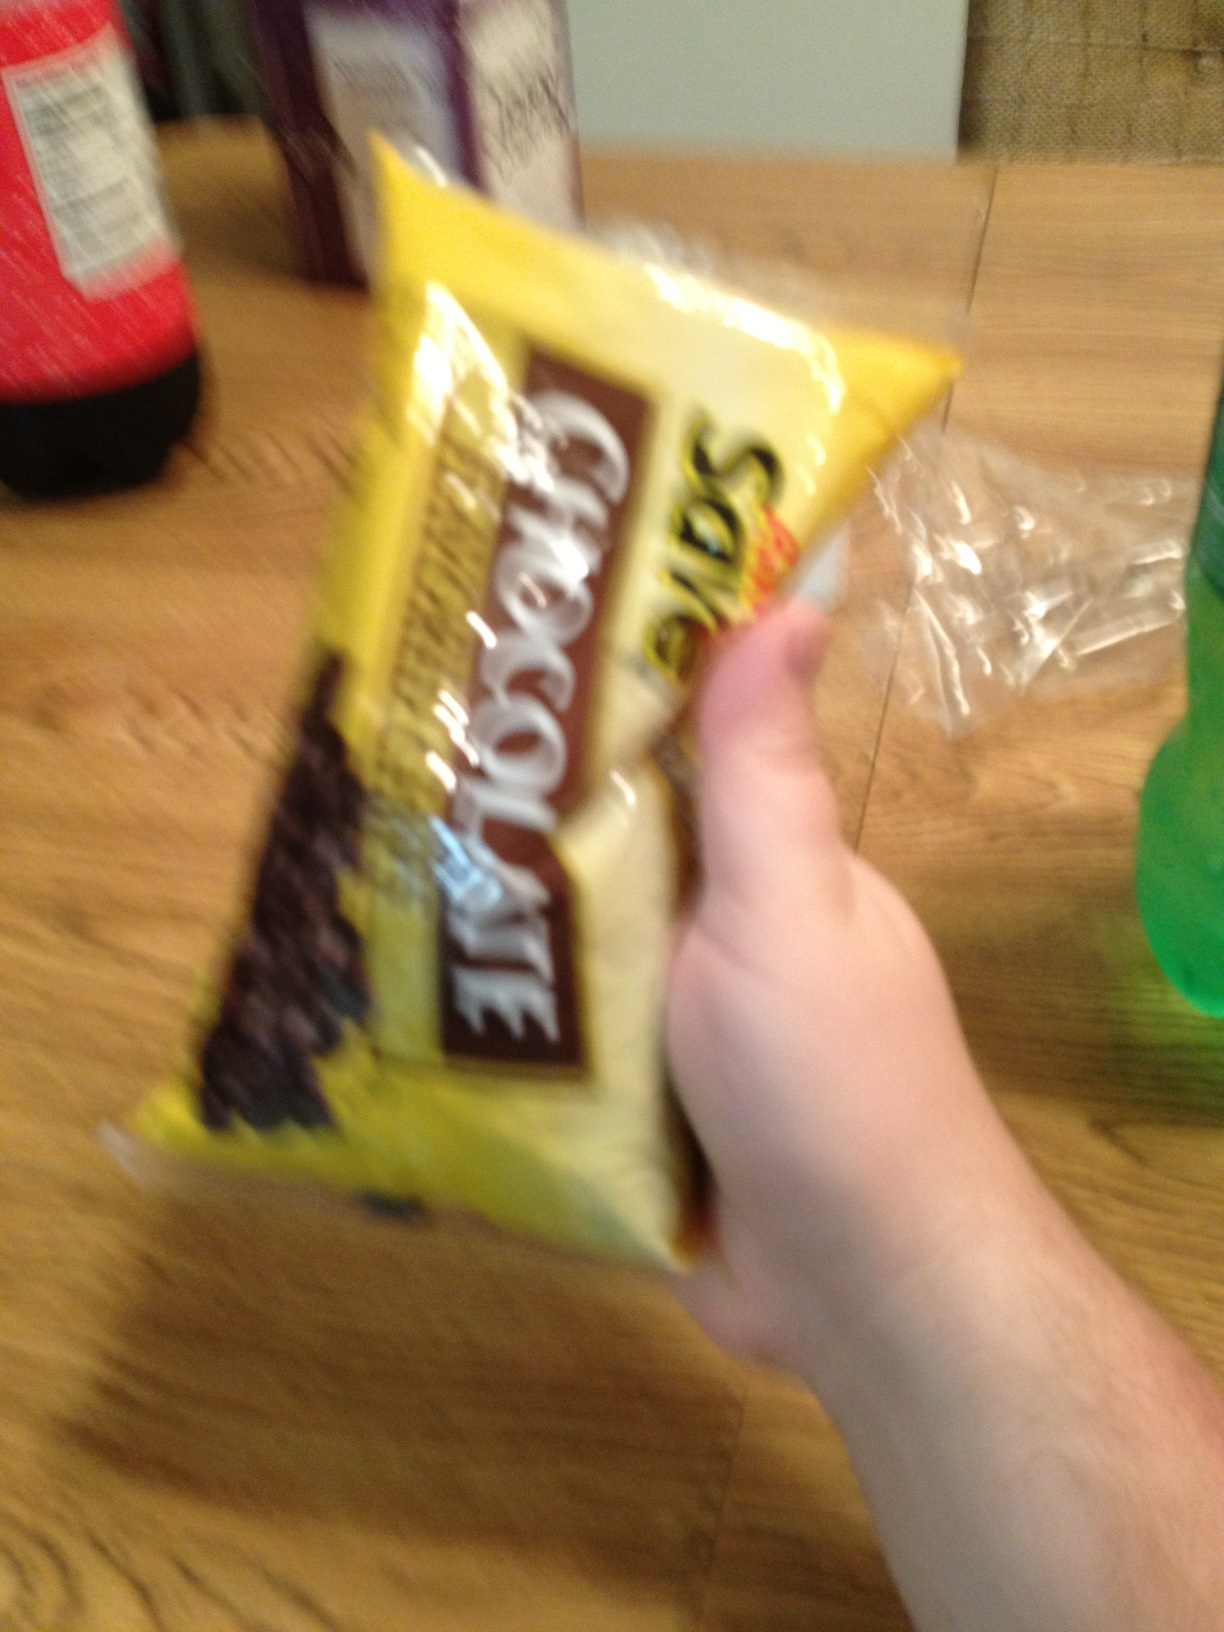Could you tell me some popular desserts that feature chocolate chips? Chocolate chips are versatile and can be featured in many desserts including chocolate chip cookies, brownies, muffins, and pancakes. They're also great in homemade granola bars or as a topping for yogurts and ice creams. 